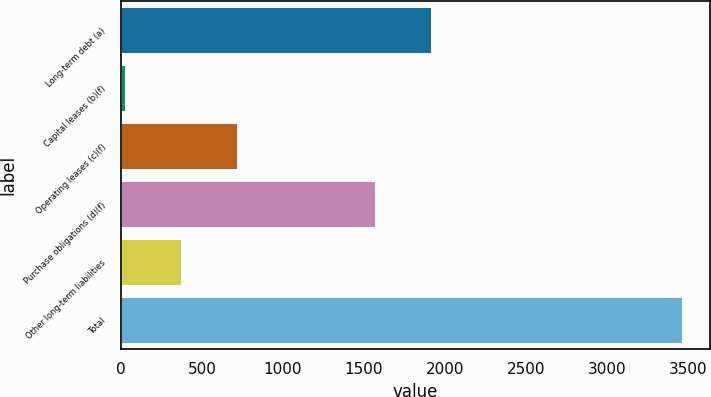Convert chart. <chart><loc_0><loc_0><loc_500><loc_500><bar_chart><fcel>Long-term debt (a)<fcel>Capital leases (b)(f)<fcel>Operating leases (c)(f)<fcel>Purchase obligations (d)(f)<fcel>Other long-term liabilities<fcel>Total<nl><fcel>1912.6<fcel>27<fcel>714.2<fcel>1569<fcel>370.6<fcel>3463<nl></chart> 